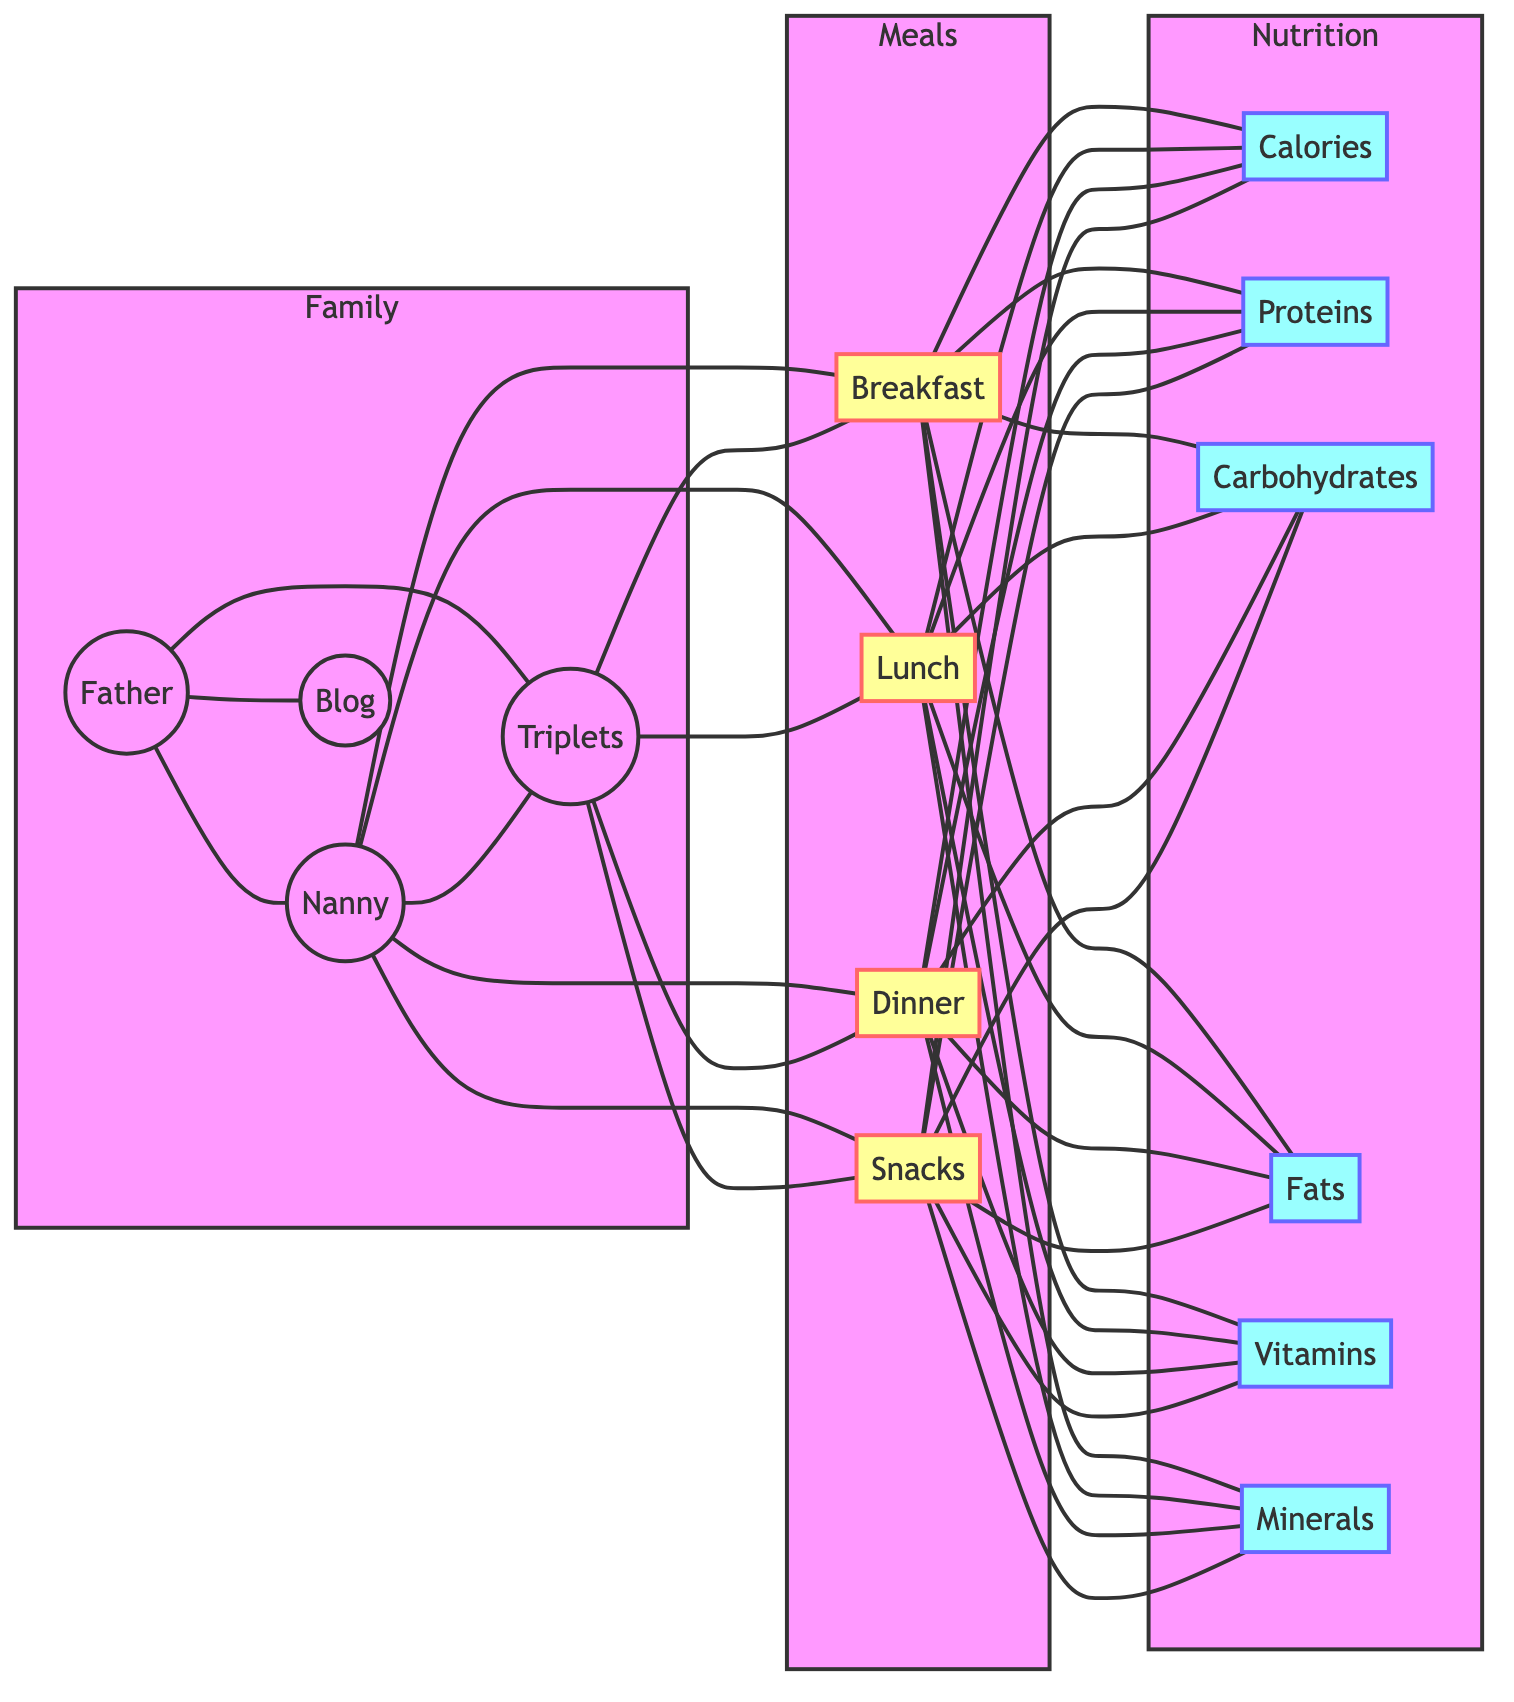What nodes are directly connected to the Nanny? The Nanny node is connected to the Triplets, Breakfast, Lunch, Dinner, and Snacks nodes, according to the edges from the diagram.
Answer: Triplets, Breakfast, Lunch, Dinner, Snacks How many meal types are represented in the diagram? The diagram includes four meal types: Breakfast, Lunch, Dinner, and Snacks. This is determined by counting the distinct meal nodes in the graph.
Answer: 4 Which nutritional components are linked to Dinner? Dinner is linked to Calories, Proteins, Carbohydrates, Fats, Vitamins, and Minerals, based on the edges connecting the Dinner node to each nutritional component node.
Answer: Calories, Proteins, Carbohydrates, Fats, Vitamins, Minerals Who is responsible for planning the meals? The Nanny is responsible for the meal planning, as indicated by the connections from the Nanny to the Breakfast, Lunch, Dinner, and Snacks nodes.
Answer: Nanny Are calories associated with all meal types? Yes, according to the edges in the diagram, Calories are connected to Breakfast, Lunch, Dinner, and Snacks, indicating that each meal type has an associated calories value.
Answer: Yes What is the relationship between the Father and the Blog? The Father node is connected to the Blog node with a direct edge, indicating a direct relationship. This shows that the Father manages the Blog.
Answer: Manages Which entities are connected to the Triplets node? The Triplets node is connected to the Father, Nanny, Breakfast, Lunch, Dinner, and Snacks nodes, highlighting the various relationships involving the triplets.
Answer: Father, Nanny, Breakfast, Lunch, Dinner, Snacks How many edges are present in the graph? By counting all the connections (edges) in the diagram, there are 40 edges in total, representing various relationships between nodes.
Answer: 40 Which meal is connected to the most nutritional components? All meal nodes (Breakfast, Lunch, Dinner, Snacks) are equally connected to six nutritional components each, namely Calories, Proteins, Carbohydrates, Fats, Vitamins, and Minerals.
Answer: All meals have the same number of connections 